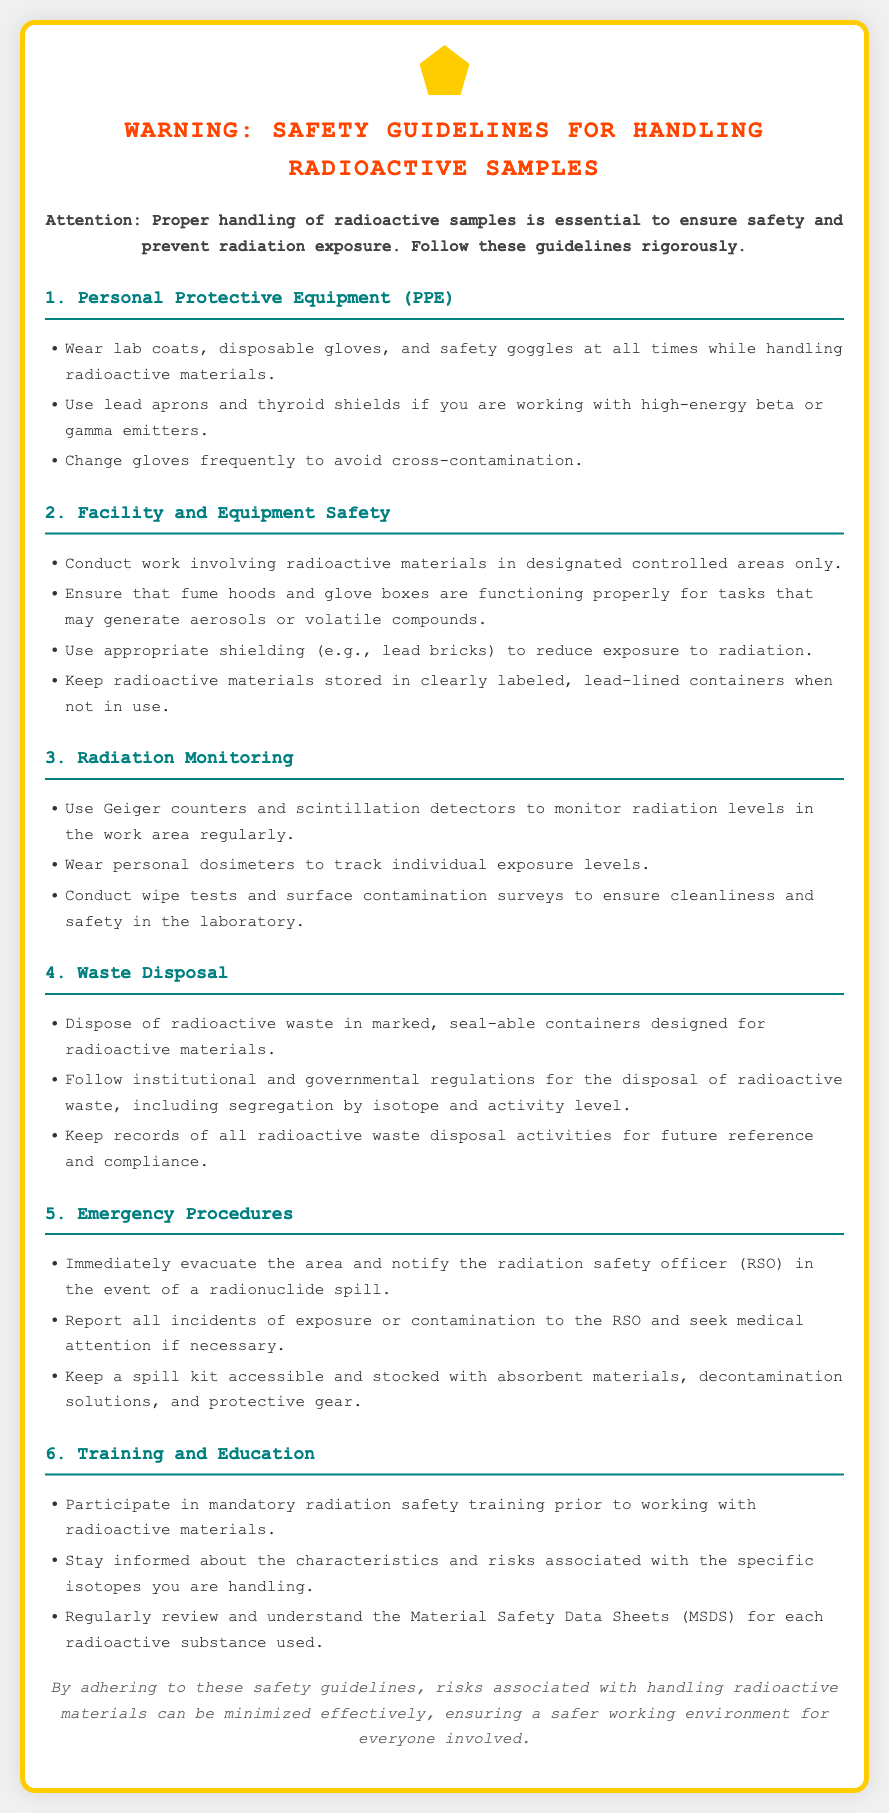What are the required PPE for handling radioactive materials? The document specifies that lab coats, disposable gloves, and safety goggles must be worn at all times while handling radioactive materials.
Answer: lab coats, disposable gloves, safety goggles What should be used to monitor radiation levels? The guidelines indicate the use of Geiger counters and scintillation detectors for monitoring radiation levels in the work area.
Answer: Geiger counters, scintillation detectors What type of containers should radioactive waste be disposed of in? The document states that radioactive waste should be disposed of in marked, seal-able containers designed for radioactive materials.
Answer: marked, seal-able containers What should you do in the event of a radionuclide spill? The instructions outline that you must immediately evacuate the area and notify the radiation safety officer (RSO) in the event of a radionuclide spill.
Answer: evacuate the area, notify RSO What is the purpose of personal dosimeters? The personal dosimeters are meant to track individual exposure levels according to the guidelines presented in the document.
Answer: track individual exposure levels How often should gloves be changed to prevent cross-contamination? The document advises changing gloves frequently to avoid cross-contamination while handling radioactive materials.
Answer: frequently What is mandatory before working with radioactive materials? The document emphasizes participation in mandatory radiation safety training prior to working with radioactive materials.
Answer: radiation safety training What should be done with records of radioactive waste disposal activities? The guidelines mention that records of radioactive waste disposal activities should be kept for future reference and compliance.
Answer: kept for future reference and compliance 